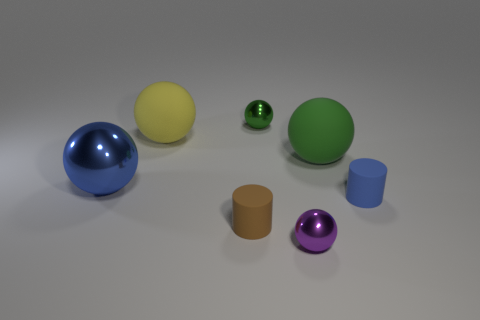Subtract all purple spheres. How many spheres are left? 4 Subtract all blue spheres. How many spheres are left? 4 Add 2 purple metal balls. How many objects exist? 9 Subtract all yellow balls. Subtract all green cylinders. How many balls are left? 4 Subtract all spheres. How many objects are left? 2 Subtract all tiny balls. Subtract all balls. How many objects are left? 0 Add 7 large green rubber spheres. How many large green rubber spheres are left? 8 Add 5 big matte balls. How many big matte balls exist? 7 Subtract 1 blue cylinders. How many objects are left? 6 